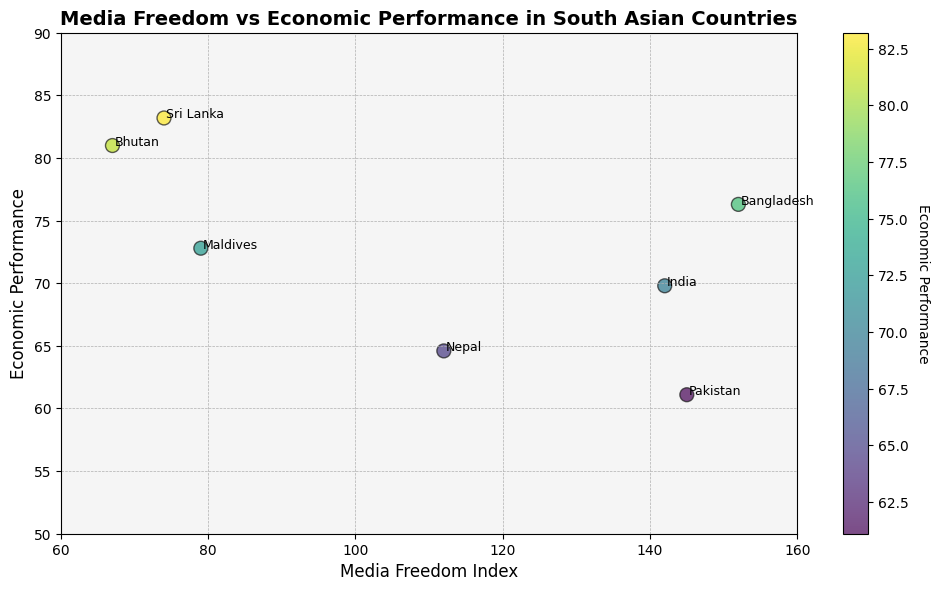What is the Media Freedom Index of the country with the highest Economic Performance? First, identify the country with the highest Economic Performance, which is Sri Lanka (83.2). The Media Freedom Index for Sri Lanka is 74.
Answer: 74 Which country has the lowest Economic Performance and what is its Media Freedom Index? The country with the lowest Economic Performance is Pakistan (61.1). The Media Freedom Index for Pakistan is 145.
Answer: Pakistan, 145 What is the difference in Economic Performance between the countries with the highest and lowest Media Freedom Index? The highest Media Freedom Index is for Bhutan (67) with an Economic Performance of 81.0, and the lowest is for Bangladesh (152) with an Economic Performance of 76.3. The difference is 81.0 - 76.3 = 4.7.
Answer: 4.7 Which country has the closest Media Freedom Index to Sri Lanka and what is its Economic Performance? The closest Media Freedom Index to Sri Lanka (74) is Maldives with 79. The Economic Performance of Maldives is 72.8.
Answer: Maldives, 72.8 Comparing Media Freedom Index and Economic Performance, which two countries have the most similar values? Bhutan (67, 81.0) and Sri Lanka (74, 83.2) have relatively close values. Another similar pair is Nepal (112, 64.6) and Pakistan (145, 61.1) if considering both factors. However, Bhutan and Sri Lanka are closer numerically.
Answer: Bhutan and Sri Lanka How does the Economic Performance of countries with Media Freedom Index less than 100 compare to those with an index greater than 100? Countries with an Index <100: Sri Lanka (83.2), Bhutan (81.0), Maldives (72.8). Countries with Index >100: India (69.8), Pakistan (61.1), Bangladesh (76.3), Nepal (64.6). Summing up and averaging the Economic Performances: <100: (83.2 + 81.0 + 72.8)/3 ≈ 79.0; >100: (69.8 + 61.1 + 76.3 + 64.6)/4 ≈ 67.95. Therefore, countries with Media Freedom Index <100 have better Economic Performance on average.
Answer: <100: Average ≈ 79.0, >100: Average ≈ 67.95 